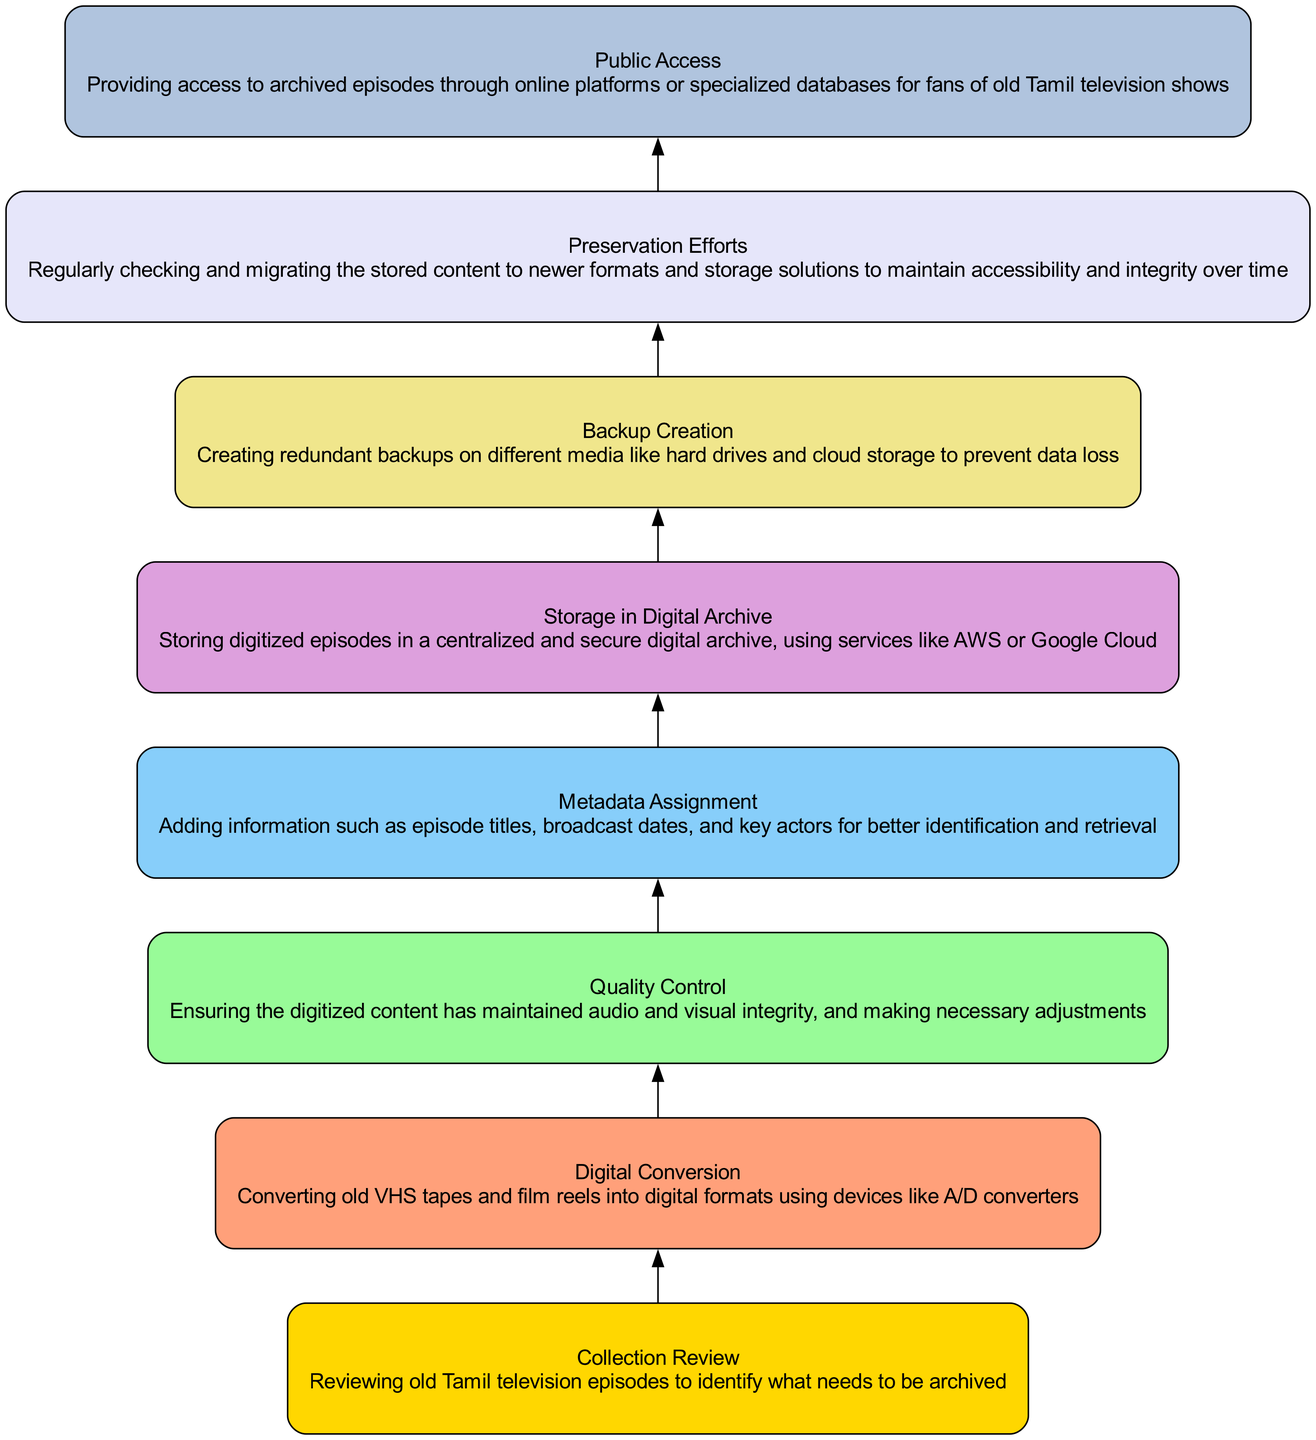What is the first step in the archiving process? The first step depicted in the diagram is "Collection Review". This is the starting point where old Tamil television episodes are reviewed to identify what needs to be archived, hence it's the first node in the flowchart.
Answer: Collection Review What follows "Quality Control" in the process? After "Quality Control", the next step is "Metadata Assignment". This is determined by following the directional arrows from one step to the next in the flowchart.
Answer: Metadata Assignment How many total steps are involved in the archiving process? There are eight total steps represented in the flowchart. This is counted by listing each node from "Collection Review" to "Public Access".
Answer: 8 Which step is immediately before "Storage in Digital Archive"? The step that comes immediately before "Storage in Digital Archive" is "Metadata Assignment". This can be derived from the ordered flow of the steps leading up to the storage phase.
Answer: Metadata Assignment What is the purpose of the "Preservation Efforts" step? "Preservation Efforts" involve regularly checking and migrating the stored content to newer formats and storage solutions. This step ensures that the archived episodes remain accessible and retain their integrity over time.
Answer: Maintaining accessibility Which two steps are directly connected by an edge? The two directly connected steps are "Digital Conversion" and "Quality Control". This connection shows the sequential relationship between converting the media and checking its quality.
Answer: Digital Conversion, Quality Control How does "Backup Creation" relate to the overall process? "Backup Creation" serves as a protective measure to create redundant backups on different media. This ensures no data loss occurs, showing its significance in the continuity and reliability of the archiving process.
Answer: Data protection Which step provides access to the archived episodes? The step that provides access to the archived episodes is "Public Access". This node signifies the output stage where fans can view the archived content.
Answer: Public Access 